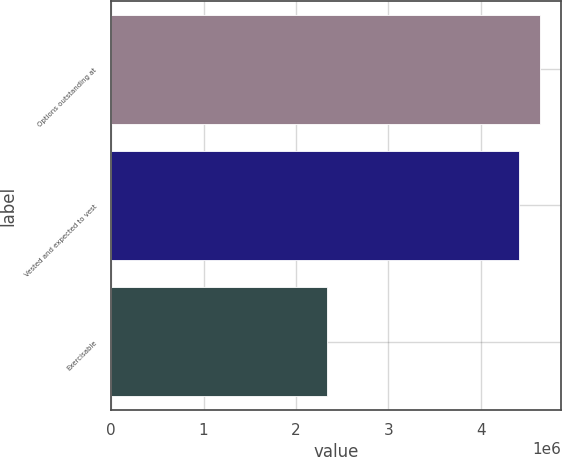Convert chart to OTSL. <chart><loc_0><loc_0><loc_500><loc_500><bar_chart><fcel>Options outstanding at<fcel>Vested and expected to vest<fcel>Exercisable<nl><fcel>4.63439e+06<fcel>4.4143e+06<fcel>2.3358e+06<nl></chart> 